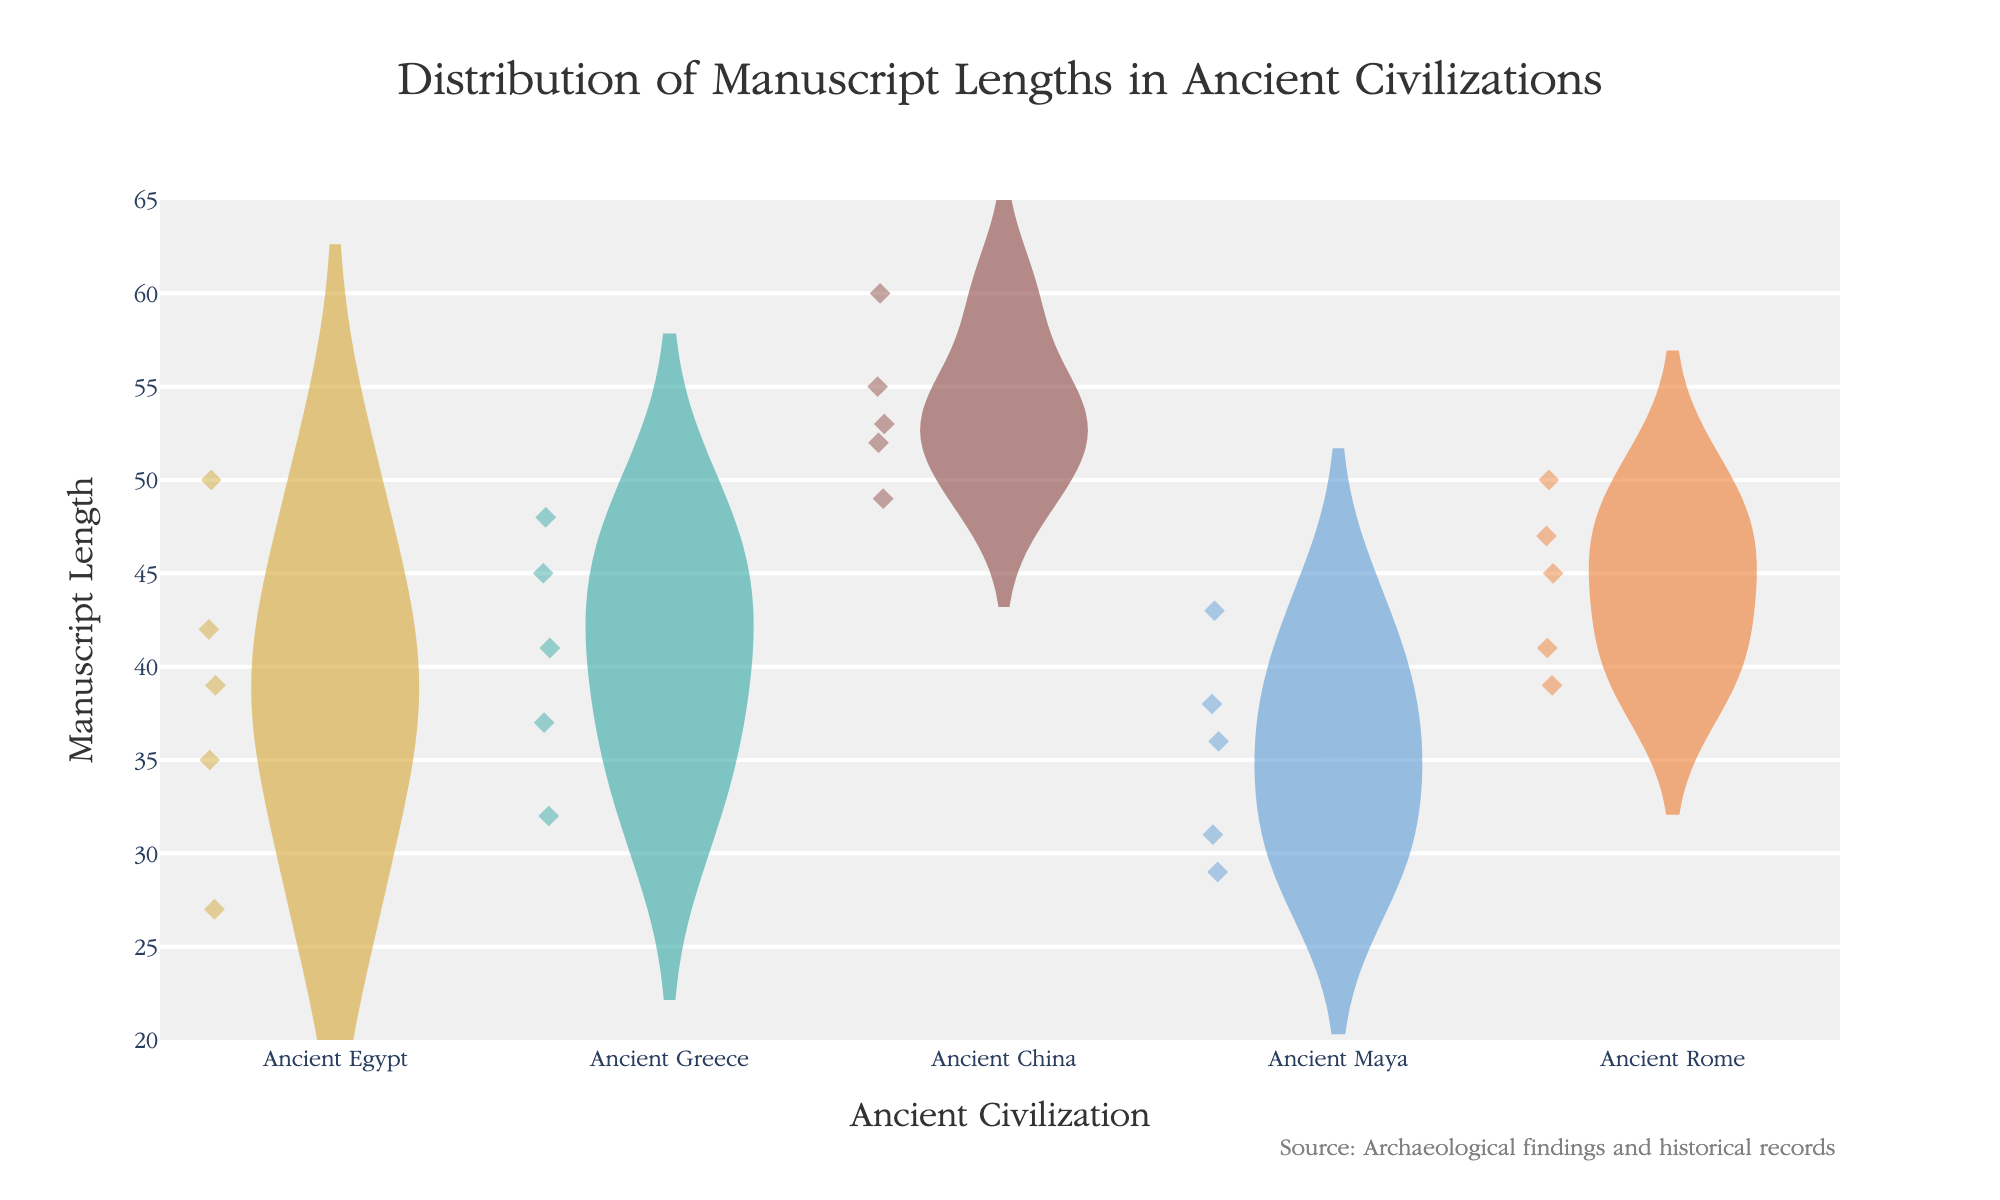What is the title of the figure? The title of the figure is provided at the top center. It reads "Distribution of Manuscript Lengths in Ancient Civilizations".
Answer: Distribution of Manuscript Lengths in Ancient Civilizations How many ancient civilizations are compared in the figure? By counting the unique categories on the x-axis, we see five different ancient civilizations: Ancient Egypt, Ancient Greece, Ancient China, Ancient Maya, and Ancient Rome.
Answer: 5 Which civilization appears to have the highest maximum manuscript length? By observing the upper ends of the violin plots, we see that Ancient China has the highest maximum value, reaching 60 units.
Answer: Ancient China What is the median manuscript length for Ancient Egypt? Each violin plot has a horizontal line representing the median. For Ancient Egypt, this line is at around the 39 mark.
Answer: 39 Which civilization has the most narrow distribution of manuscript lengths? By observing the width of the violin plots, Ancient Maya has the narrowest distribution, with lengths mainly between 29 and 43 units.
Answer: Ancient Maya What is the range of manuscript lengths for Ancient Rome? The range is the difference between the maximum and minimum values. For Ancient Rome, the manuscript lengths range from 39 to 50 units, giving a range of 50 - 39 = 11.
Answer: 11 Which civilization has the most data points shown on the plot? By counting the individual points (diamonds) within each violin plot, Ancient China has the most data points with five points visible.
Answer: Ancient China Which two civilizations have a similar median manuscript length? By comparing the horizontal median lines, Ancient Greece and Ancient Rome both have medians around the 45 mark.
Answer: Ancient Greece and Ancient Rome Is the distribution of manuscript lengths for Ancient Greece skewed? If so, in which direction? By looking at the shape of the violin plot for Ancient Greece, there is a slight skew towards the higher values, indicating a right skew (positive skew).
Answer: Right skew 